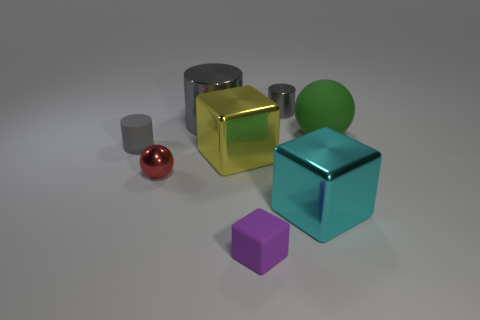Subtract 1 cylinders. How many cylinders are left? 2 Add 1 large cyan rubber things. How many objects exist? 9 Subtract all spheres. How many objects are left? 6 Subtract all yellow cubes. Subtract all big cyan cubes. How many objects are left? 6 Add 8 small matte cylinders. How many small matte cylinders are left? 9 Add 1 green objects. How many green objects exist? 2 Subtract 0 brown blocks. How many objects are left? 8 